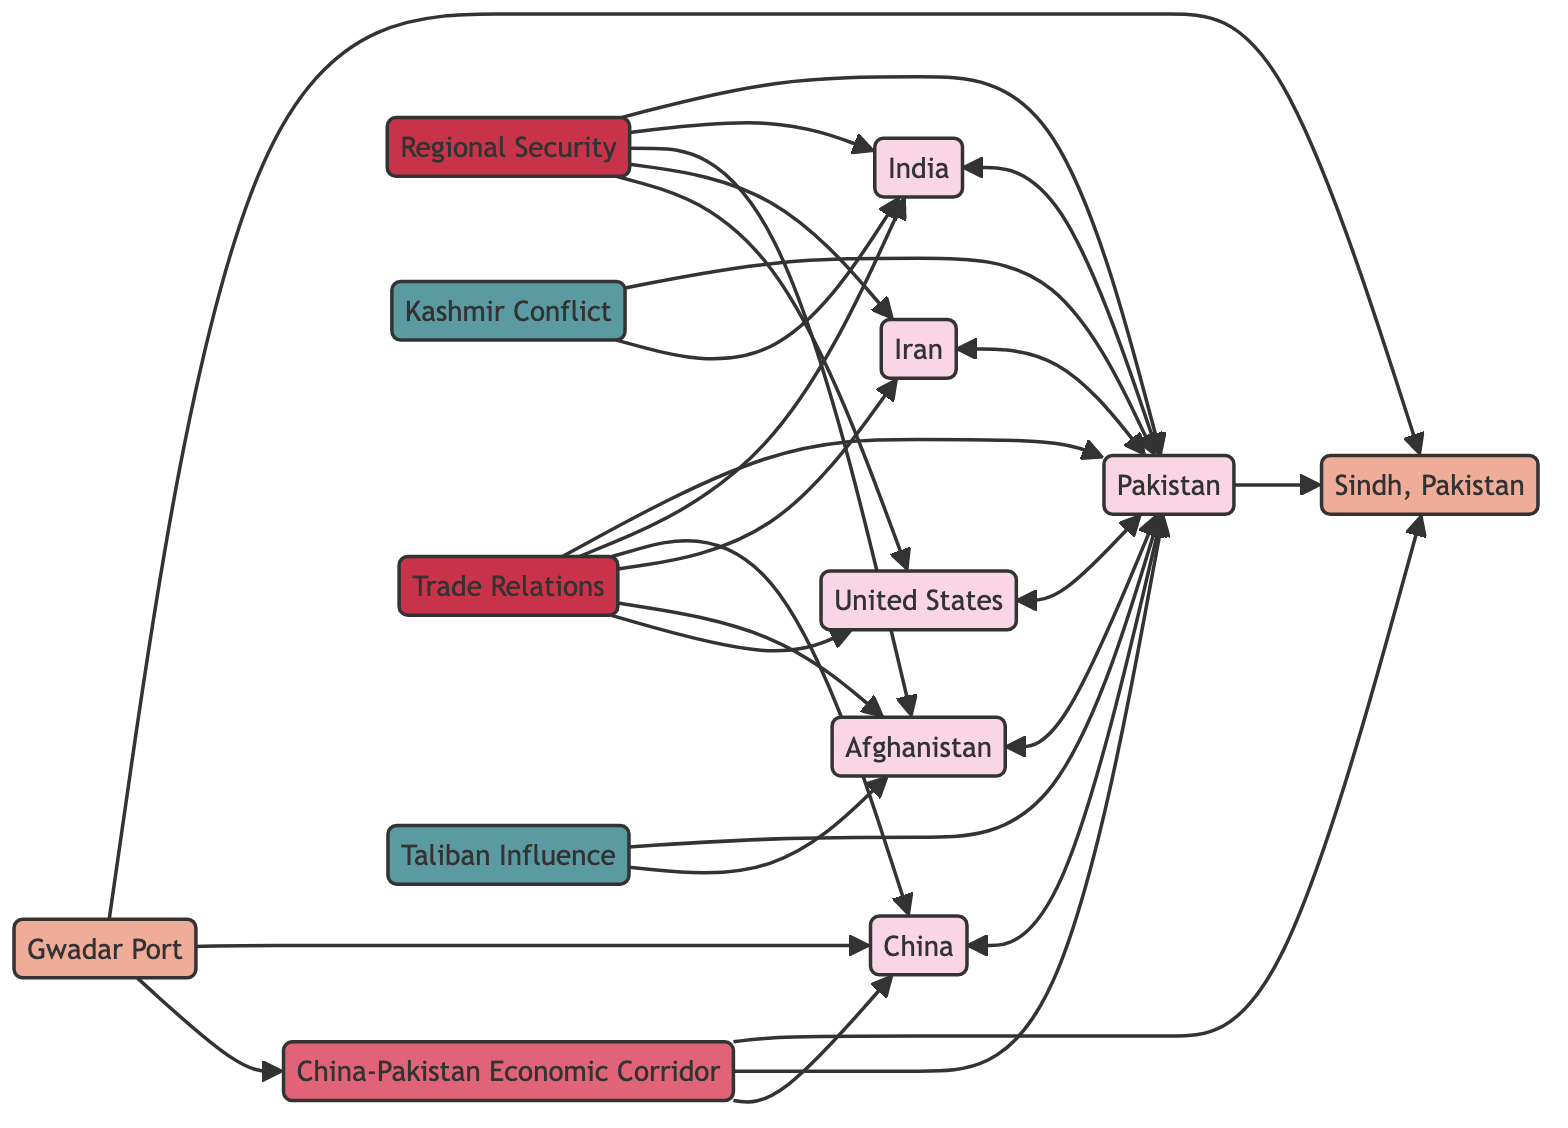What is the primary entity representing Sindh in the diagram? The diagram features "Sindh, Pakistan" as the primary entity linked to "Pakistan." This can be identified by observing the node labeled "Sindh, Pakistan" and its direct connection to the "Pakistan" node.
Answer: Sindh, Pakistan How many countries are directly linked to Pakistan? The diagram shows that there are five countries that have direct links to Pakistan: India, China, Iran, Afghanistan, and the United States. This can be counted by looking at the connections stemming from the "Pakistan" node.
Answer: 5 What initiative is associated with Sindh and involves China? The "China-Pakistan Economic Corridor (CPEC)" is the initiative linked with "Sindh" and "China." This is deduced from the node labeled "CPEC" that connects to both "Sindh" and "China."
Answer: China-Pakistan Economic Corridor (CPEC) Which issue is specifically linked to both Pakistan and Afghanistan? "Taliban Influence" is the issue that connects Pakistan and Afghanistan. By examining the "Taliban" node, we can see it has links to both "Pakistan" and "Afghanistan."
Answer: Taliban Influence How does the "Gwadar Port" relate to both CPEC and Sindh? "Gwadar Port" is linked to both "CPEC" and "Sindh." This is confirmed by looking at the connections from the "Gwadar Port" node, which indicates its relevance to both nodes.
Answer: Gwadar Port Which country is involved in the Kashmir Conflict according to the diagram? The countries involved in the Kashmir Conflict are "Pakistan" and "India." This information is clear from the direct link labeled "Kashmir Conflict" connecting both country nodes.
Answer: Pakistan, India What category includes issues related to security in the region? The category labeled "Regional Security" encompasses issues related to security involving Pakistan, India, Afghanistan, Iran, and the United States. This can be seen by identifying the "Regional Security" node and the links to the respective countries.
Answer: Regional Security Which country has trade relations with Afghanistan, as per the diagram? The diagram indicates that "Pakistan" has trade relations with "Afghanistan," as both have a direct link to the "Trade Relations" category node.
Answer: Pakistan 